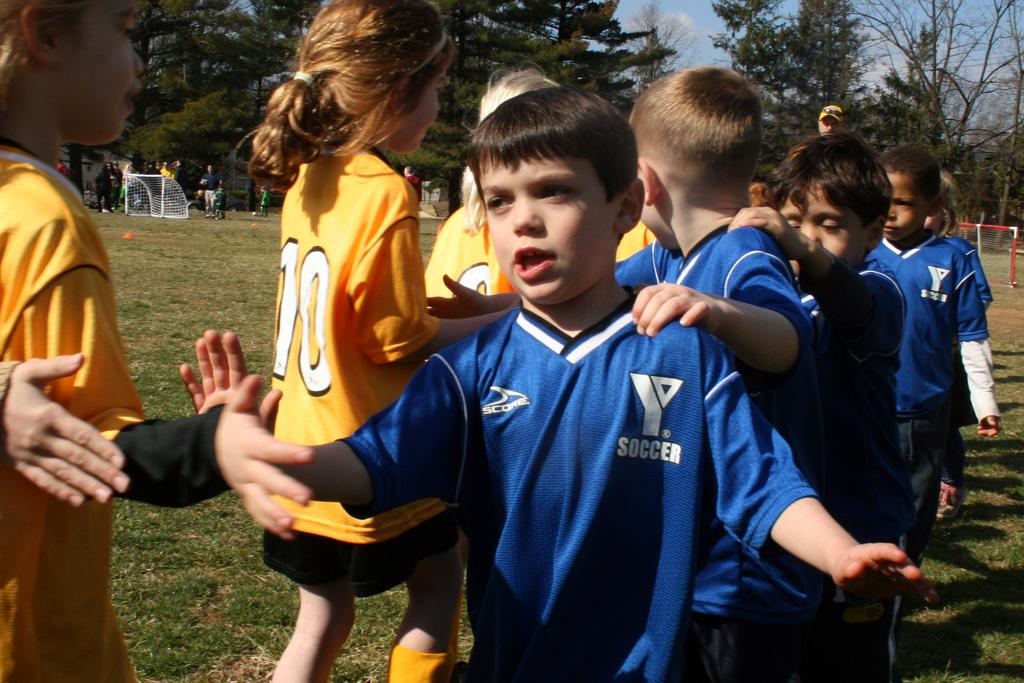<image>
Render a clear and concise summary of the photo. A group of children in soccer uniforms that say Score are giving each other high fives. 